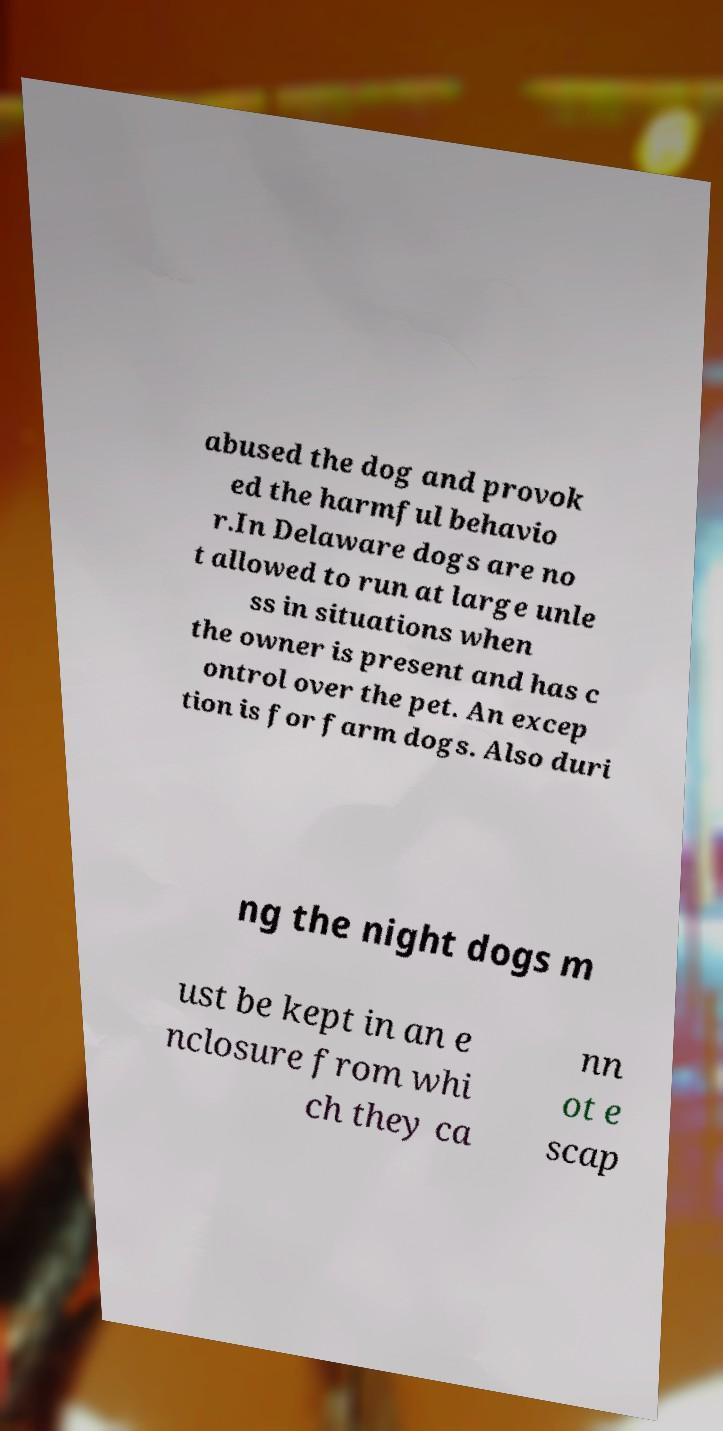Please identify and transcribe the text found in this image. abused the dog and provok ed the harmful behavio r.In Delaware dogs are no t allowed to run at large unle ss in situations when the owner is present and has c ontrol over the pet. An excep tion is for farm dogs. Also duri ng the night dogs m ust be kept in an e nclosure from whi ch they ca nn ot e scap 